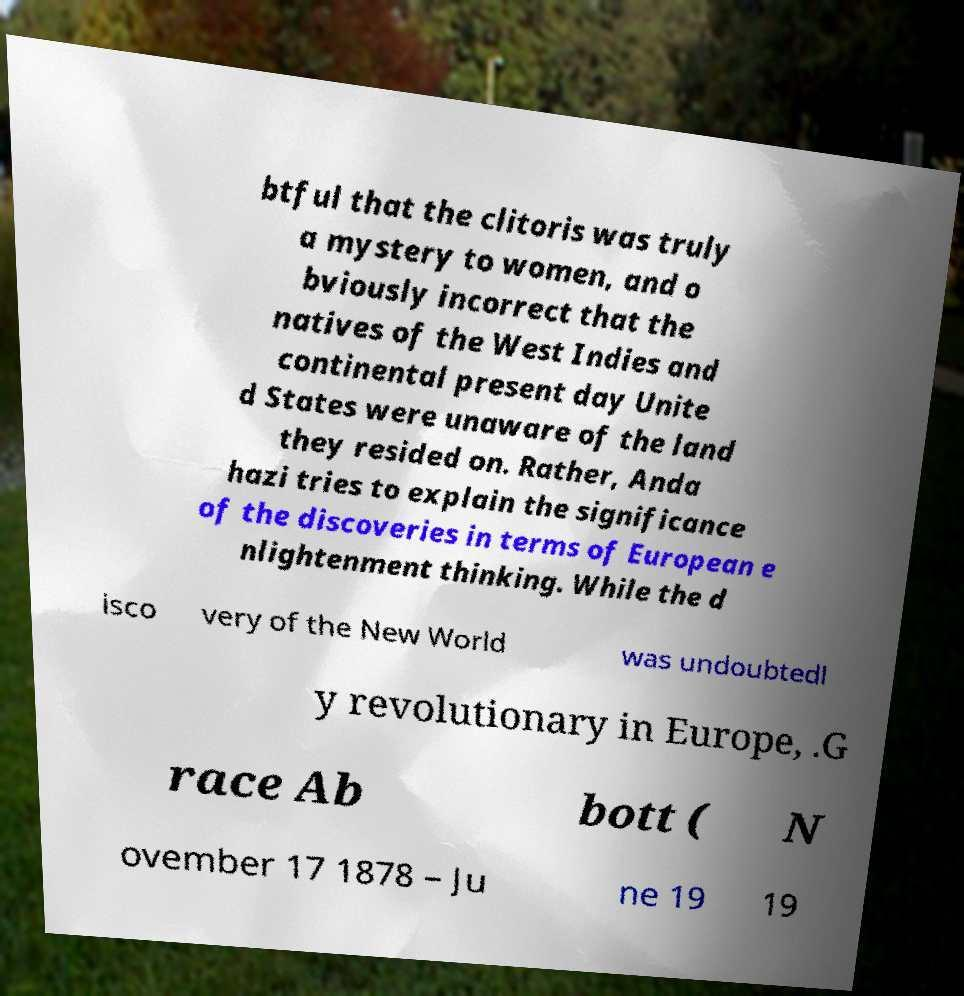Can you read and provide the text displayed in the image?This photo seems to have some interesting text. Can you extract and type it out for me? btful that the clitoris was truly a mystery to women, and o bviously incorrect that the natives of the West Indies and continental present day Unite d States were unaware of the land they resided on. Rather, Anda hazi tries to explain the significance of the discoveries in terms of European e nlightenment thinking. While the d isco very of the New World was undoubtedl y revolutionary in Europe, .G race Ab bott ( N ovember 17 1878 – Ju ne 19 19 